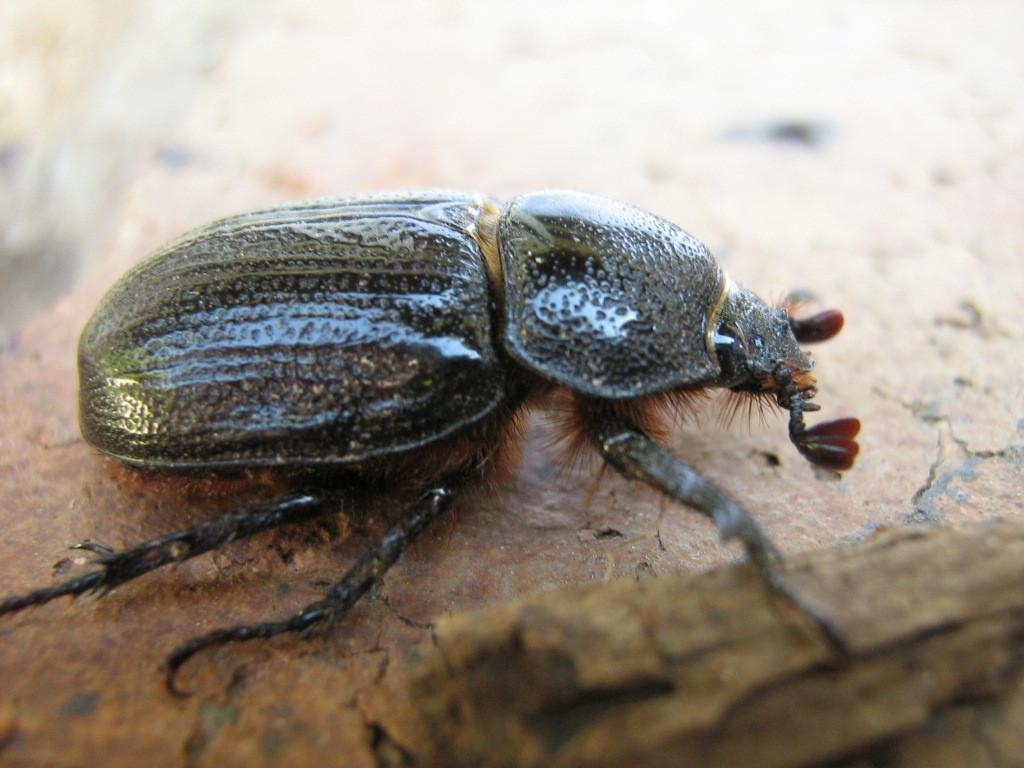What type of creature is present in the image? There is an insect in the image. Where is the insect located in the image? The insect is on a surface. What type of shame is the insect feeling in the image? There is no indication of shame in the image, as insects do not experience emotions like humans do. 